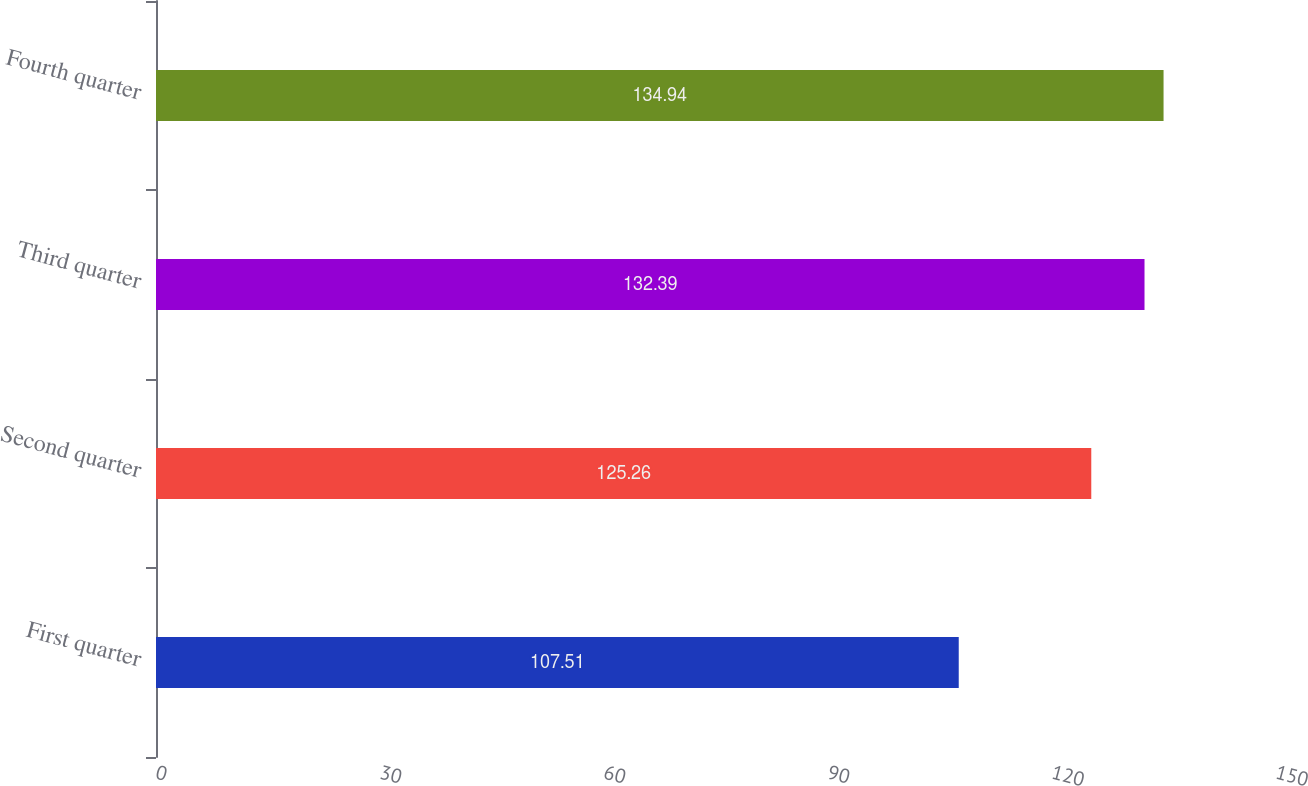Convert chart. <chart><loc_0><loc_0><loc_500><loc_500><bar_chart><fcel>First quarter<fcel>Second quarter<fcel>Third quarter<fcel>Fourth quarter<nl><fcel>107.51<fcel>125.26<fcel>132.39<fcel>134.94<nl></chart> 